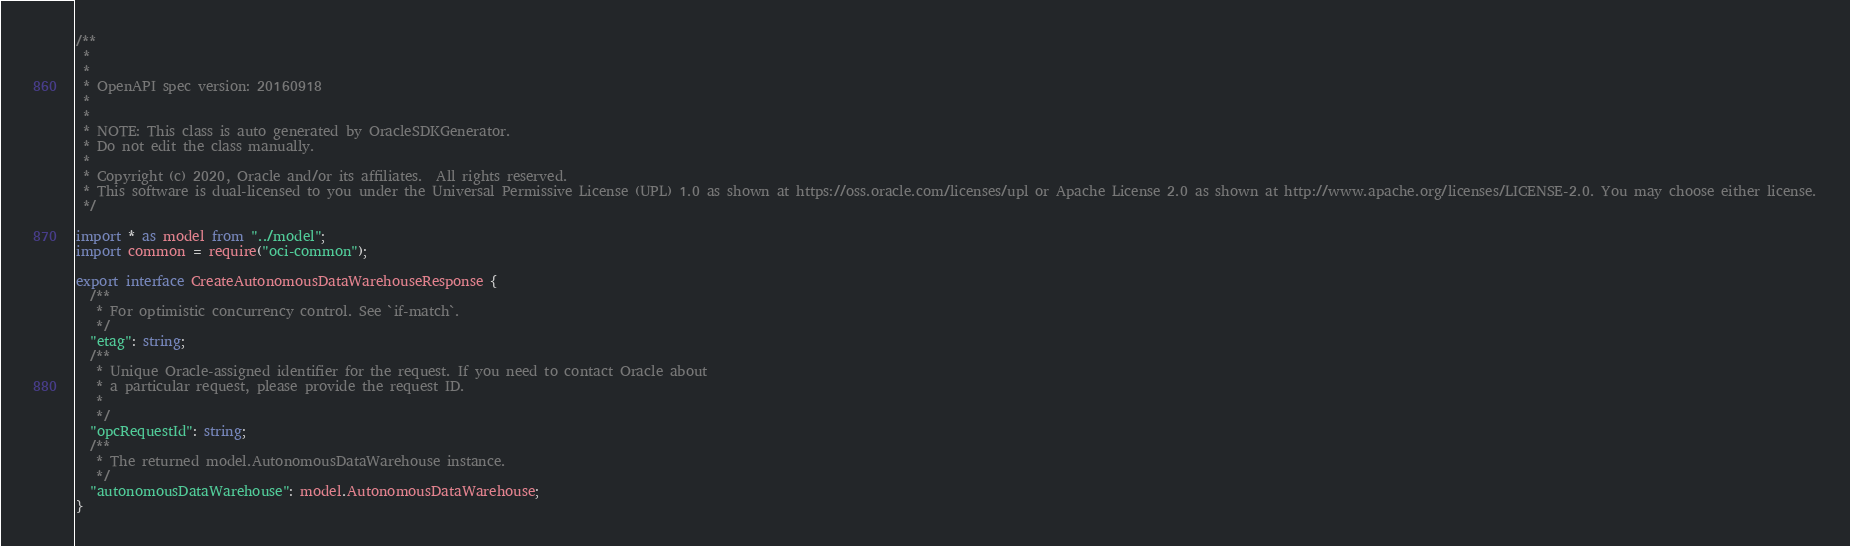<code> <loc_0><loc_0><loc_500><loc_500><_TypeScript_>/**
 *
 *
 * OpenAPI spec version: 20160918
 *
 *
 * NOTE: This class is auto generated by OracleSDKGenerator.
 * Do not edit the class manually.
 *
 * Copyright (c) 2020, Oracle and/or its affiliates.  All rights reserved.
 * This software is dual-licensed to you under the Universal Permissive License (UPL) 1.0 as shown at https://oss.oracle.com/licenses/upl or Apache License 2.0 as shown at http://www.apache.org/licenses/LICENSE-2.0. You may choose either license.
 */

import * as model from "../model";
import common = require("oci-common");

export interface CreateAutonomousDataWarehouseResponse {
  /**
   * For optimistic concurrency control. See `if-match`.
   */
  "etag": string;
  /**
   * Unique Oracle-assigned identifier for the request. If you need to contact Oracle about
   * a particular request, please provide the request ID.
   *
   */
  "opcRequestId": string;
  /**
   * The returned model.AutonomousDataWarehouse instance.
   */
  "autonomousDataWarehouse": model.AutonomousDataWarehouse;
}
</code> 